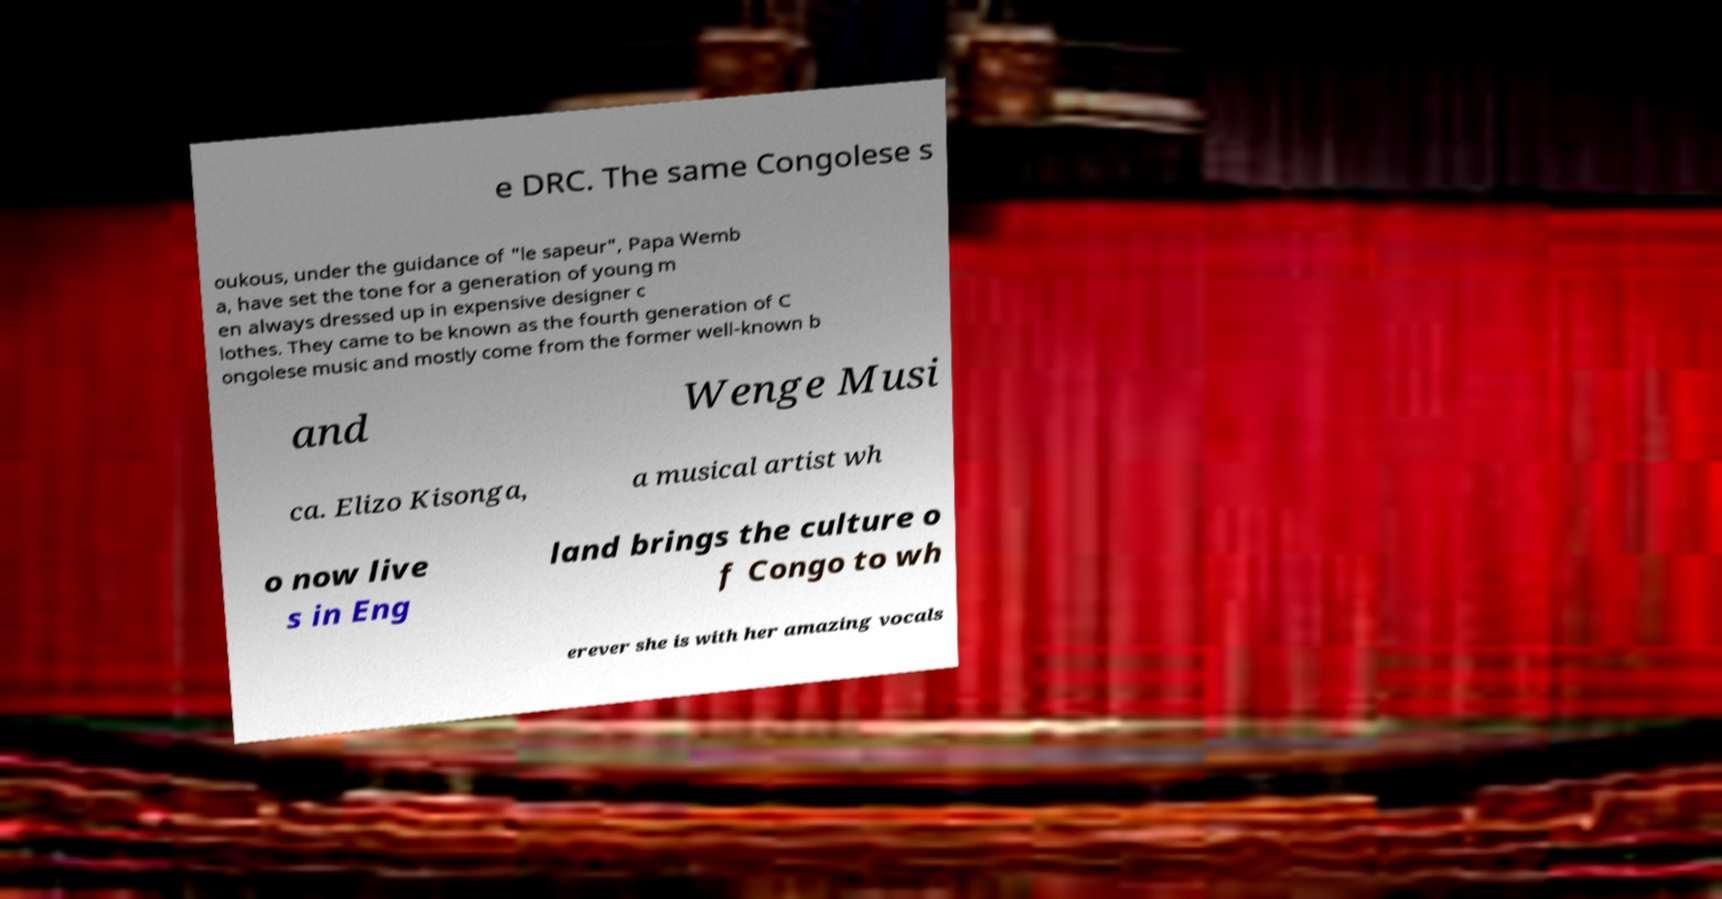Could you extract and type out the text from this image? e DRC. The same Congolese s oukous, under the guidance of "le sapeur", Papa Wemb a, have set the tone for a generation of young m en always dressed up in expensive designer c lothes. They came to be known as the fourth generation of C ongolese music and mostly come from the former well-known b and Wenge Musi ca. Elizo Kisonga, a musical artist wh o now live s in Eng land brings the culture o f Congo to wh erever she is with her amazing vocals 